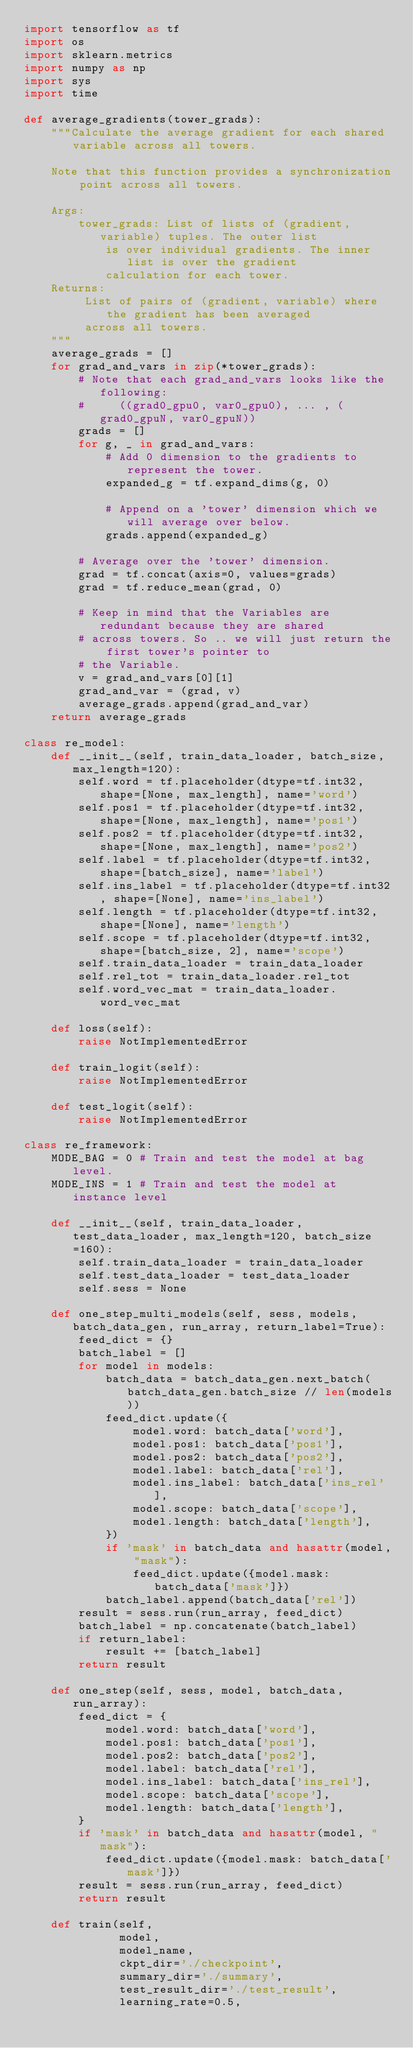<code> <loc_0><loc_0><loc_500><loc_500><_Python_>import tensorflow as tf
import os
import sklearn.metrics
import numpy as np
import sys
import time

def average_gradients(tower_grads):
    """Calculate the average gradient for each shared variable across all towers.

    Note that this function provides a synchronization point across all towers.

    Args:
        tower_grads: List of lists of (gradient, variable) tuples. The outer list
            is over individual gradients. The inner list is over the gradient
            calculation for each tower.
    Returns:
         List of pairs of (gradient, variable) where the gradient has been averaged
         across all towers.
    """
    average_grads = []
    for grad_and_vars in zip(*tower_grads):
        # Note that each grad_and_vars looks like the following:
        #     ((grad0_gpu0, var0_gpu0), ... , (grad0_gpuN, var0_gpuN))
        grads = []
        for g, _ in grad_and_vars:
            # Add 0 dimension to the gradients to represent the tower.
            expanded_g = tf.expand_dims(g, 0)

            # Append on a 'tower' dimension which we will average over below.
            grads.append(expanded_g)

        # Average over the 'tower' dimension.
        grad = tf.concat(axis=0, values=grads)
        grad = tf.reduce_mean(grad, 0)

        # Keep in mind that the Variables are redundant because they are shared
        # across towers. So .. we will just return the first tower's pointer to
        # the Variable.
        v = grad_and_vars[0][1]
        grad_and_var = (grad, v)
        average_grads.append(grad_and_var)
    return average_grads

class re_model:
    def __init__(self, train_data_loader, batch_size, max_length=120):
        self.word = tf.placeholder(dtype=tf.int32, shape=[None, max_length], name='word')
        self.pos1 = tf.placeholder(dtype=tf.int32, shape=[None, max_length], name='pos1')
        self.pos2 = tf.placeholder(dtype=tf.int32, shape=[None, max_length], name='pos2')
        self.label = tf.placeholder(dtype=tf.int32, shape=[batch_size], name='label')
        self.ins_label = tf.placeholder(dtype=tf.int32, shape=[None], name='ins_label')
        self.length = tf.placeholder(dtype=tf.int32, shape=[None], name='length')
        self.scope = tf.placeholder(dtype=tf.int32, shape=[batch_size, 2], name='scope')
        self.train_data_loader = train_data_loader
        self.rel_tot = train_data_loader.rel_tot
        self.word_vec_mat = train_data_loader.word_vec_mat

    def loss(self):
        raise NotImplementedError
    
    def train_logit(self):
        raise NotImplementedError
    
    def test_logit(self):
        raise NotImplementedError

class re_framework:
    MODE_BAG = 0 # Train and test the model at bag level.
    MODE_INS = 1 # Train and test the model at instance level

    def __init__(self, train_data_loader, test_data_loader, max_length=120, batch_size=160):
        self.train_data_loader = train_data_loader
        self.test_data_loader = test_data_loader
        self.sess = None

    def one_step_multi_models(self, sess, models, batch_data_gen, run_array, return_label=True):
        feed_dict = {}
        batch_label = []
        for model in models:
            batch_data = batch_data_gen.next_batch(batch_data_gen.batch_size // len(models))
            feed_dict.update({
                model.word: batch_data['word'],
                model.pos1: batch_data['pos1'],
                model.pos2: batch_data['pos2'],
                model.label: batch_data['rel'],
                model.ins_label: batch_data['ins_rel'],
                model.scope: batch_data['scope'],
                model.length: batch_data['length'],
            })
            if 'mask' in batch_data and hasattr(model, "mask"):
                feed_dict.update({model.mask: batch_data['mask']})
            batch_label.append(batch_data['rel'])
        result = sess.run(run_array, feed_dict)
        batch_label = np.concatenate(batch_label)
        if return_label:
            result += [batch_label]
        return result

    def one_step(self, sess, model, batch_data, run_array):
        feed_dict = {
            model.word: batch_data['word'],
            model.pos1: batch_data['pos1'],
            model.pos2: batch_data['pos2'],
            model.label: batch_data['rel'],
            model.ins_label: batch_data['ins_rel'],
            model.scope: batch_data['scope'],
            model.length: batch_data['length'],
        }
        if 'mask' in batch_data and hasattr(model, "mask"):
            feed_dict.update({model.mask: batch_data['mask']})
        result = sess.run(run_array, feed_dict)
        return result

    def train(self,
              model,
              model_name,
              ckpt_dir='./checkpoint',
              summary_dir='./summary',
              test_result_dir='./test_result',
              learning_rate=0.5,</code> 